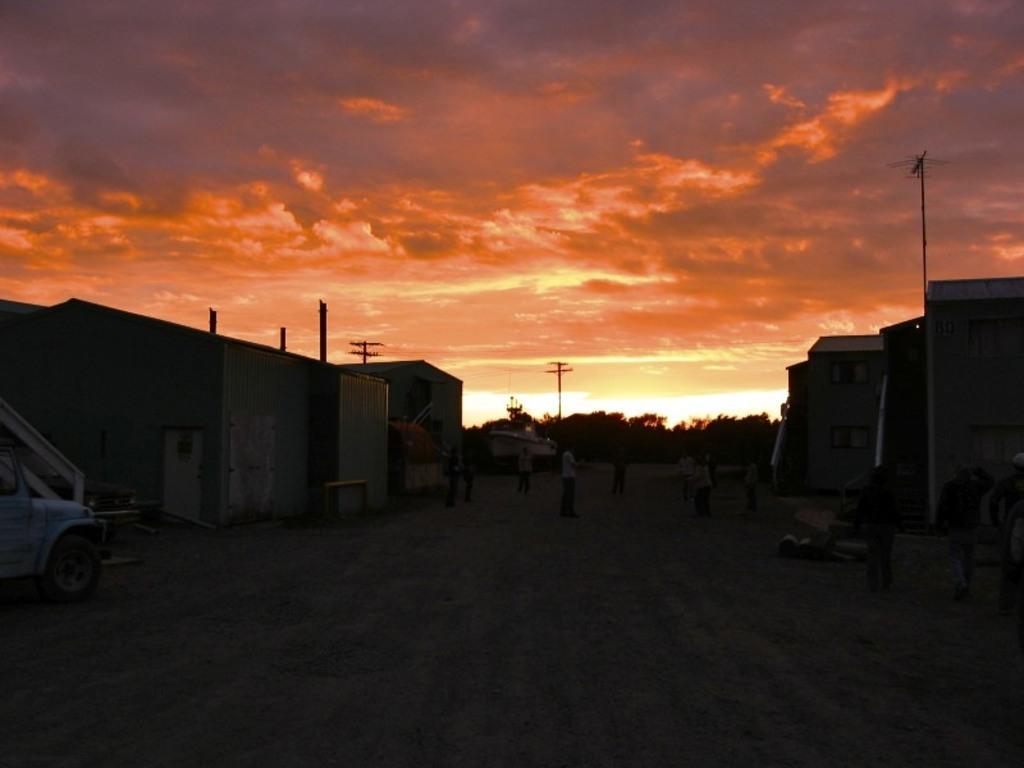How would you summarize this image in a sentence or two? On the right and left side of the image there are houses. In the middle of the houses there are few persons standing on the road. On the left side of the image there is a vehicle parked. In the background there are trees and sky. 